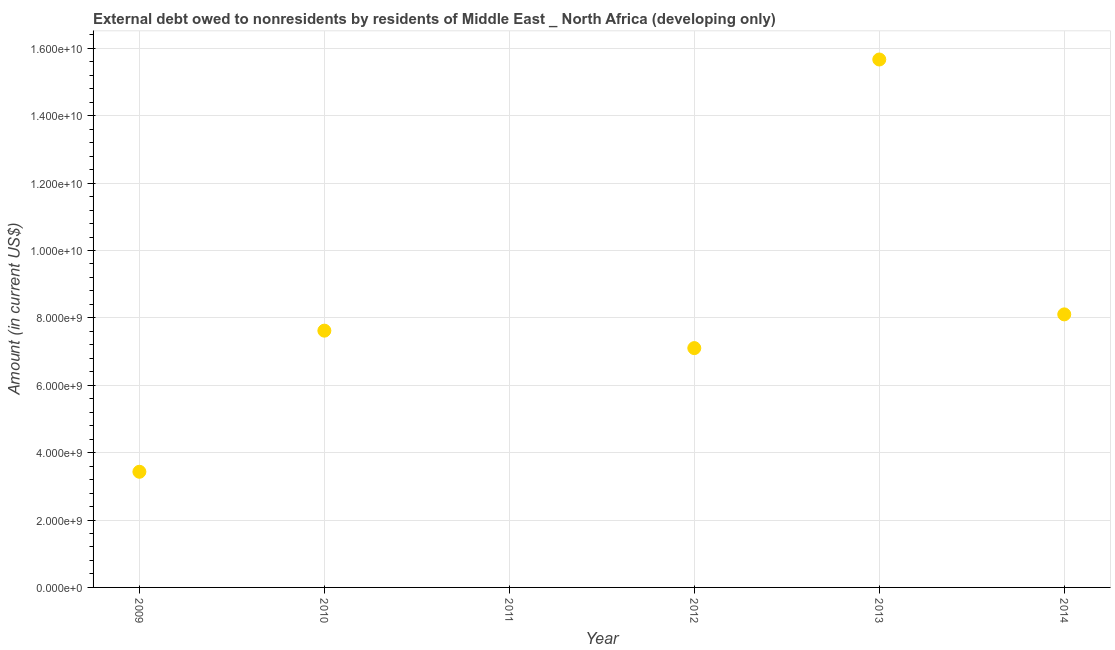What is the debt in 2009?
Provide a short and direct response. 3.43e+09. Across all years, what is the maximum debt?
Give a very brief answer. 1.57e+1. In which year was the debt maximum?
Offer a very short reply. 2013. What is the sum of the debt?
Your answer should be very brief. 4.19e+1. What is the difference between the debt in 2013 and 2014?
Your answer should be very brief. 7.56e+09. What is the average debt per year?
Your answer should be compact. 6.99e+09. What is the median debt?
Give a very brief answer. 7.36e+09. In how many years, is the debt greater than 13200000000 US$?
Offer a very short reply. 1. What is the ratio of the debt in 2010 to that in 2014?
Keep it short and to the point. 0.94. Is the difference between the debt in 2013 and 2014 greater than the difference between any two years?
Offer a very short reply. No. What is the difference between the highest and the second highest debt?
Make the answer very short. 7.56e+09. What is the difference between the highest and the lowest debt?
Your answer should be very brief. 1.57e+1. How many dotlines are there?
Make the answer very short. 1. What is the difference between two consecutive major ticks on the Y-axis?
Your answer should be compact. 2.00e+09. Are the values on the major ticks of Y-axis written in scientific E-notation?
Provide a short and direct response. Yes. Does the graph contain any zero values?
Your answer should be compact. Yes. What is the title of the graph?
Provide a short and direct response. External debt owed to nonresidents by residents of Middle East _ North Africa (developing only). What is the label or title of the X-axis?
Your answer should be compact. Year. What is the label or title of the Y-axis?
Provide a short and direct response. Amount (in current US$). What is the Amount (in current US$) in 2009?
Offer a very short reply. 3.43e+09. What is the Amount (in current US$) in 2010?
Ensure brevity in your answer.  7.62e+09. What is the Amount (in current US$) in 2012?
Keep it short and to the point. 7.10e+09. What is the Amount (in current US$) in 2013?
Provide a succinct answer. 1.57e+1. What is the Amount (in current US$) in 2014?
Make the answer very short. 8.10e+09. What is the difference between the Amount (in current US$) in 2009 and 2010?
Offer a very short reply. -4.19e+09. What is the difference between the Amount (in current US$) in 2009 and 2012?
Keep it short and to the point. -3.67e+09. What is the difference between the Amount (in current US$) in 2009 and 2013?
Give a very brief answer. -1.22e+1. What is the difference between the Amount (in current US$) in 2009 and 2014?
Your answer should be compact. -4.67e+09. What is the difference between the Amount (in current US$) in 2010 and 2012?
Your answer should be compact. 5.18e+08. What is the difference between the Amount (in current US$) in 2010 and 2013?
Provide a short and direct response. -8.05e+09. What is the difference between the Amount (in current US$) in 2010 and 2014?
Your response must be concise. -4.83e+08. What is the difference between the Amount (in current US$) in 2012 and 2013?
Offer a terse response. -8.57e+09. What is the difference between the Amount (in current US$) in 2012 and 2014?
Offer a terse response. -1.00e+09. What is the difference between the Amount (in current US$) in 2013 and 2014?
Provide a short and direct response. 7.56e+09. What is the ratio of the Amount (in current US$) in 2009 to that in 2010?
Your answer should be very brief. 0.45. What is the ratio of the Amount (in current US$) in 2009 to that in 2012?
Give a very brief answer. 0.48. What is the ratio of the Amount (in current US$) in 2009 to that in 2013?
Offer a very short reply. 0.22. What is the ratio of the Amount (in current US$) in 2009 to that in 2014?
Give a very brief answer. 0.42. What is the ratio of the Amount (in current US$) in 2010 to that in 2012?
Provide a succinct answer. 1.07. What is the ratio of the Amount (in current US$) in 2010 to that in 2013?
Your response must be concise. 0.49. What is the ratio of the Amount (in current US$) in 2010 to that in 2014?
Provide a short and direct response. 0.94. What is the ratio of the Amount (in current US$) in 2012 to that in 2013?
Offer a very short reply. 0.45. What is the ratio of the Amount (in current US$) in 2012 to that in 2014?
Your response must be concise. 0.88. What is the ratio of the Amount (in current US$) in 2013 to that in 2014?
Offer a terse response. 1.93. 